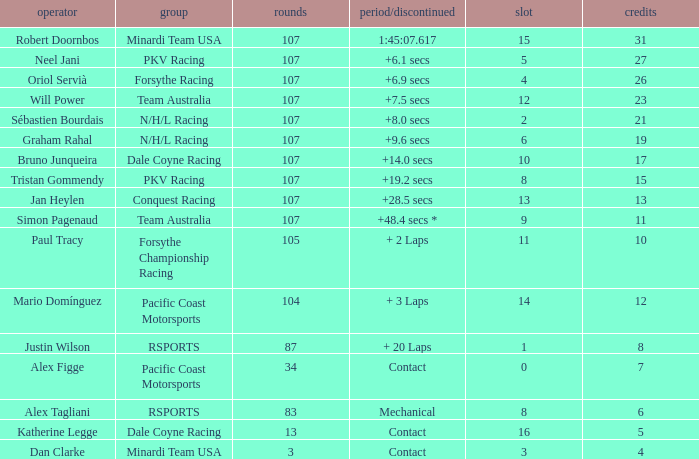What is the highest number of points scored by minardi team usa in more than 13 laps? 31.0. 